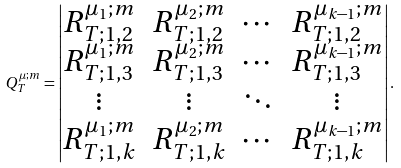Convert formula to latex. <formula><loc_0><loc_0><loc_500><loc_500>Q _ { T } ^ { \mu ; m } = \begin{vmatrix} R _ { T ; 1 , 2 } ^ { \mu _ { 1 } ; m } & R _ { T ; 1 , 2 } ^ { \mu _ { 2 } ; m } & \cdots & R _ { T ; 1 , 2 } ^ { \mu _ { k - 1 } ; m } \\ R _ { T ; 1 , 3 } ^ { \mu _ { 1 } ; m } & R _ { T ; 1 , 3 } ^ { \mu _ { 2 } ; m } & \cdots & R _ { T ; 1 , 3 } ^ { \mu _ { k - 1 } ; m } \\ \vdots & \vdots & \ddots & \vdots \\ R _ { T ; 1 , k } ^ { \mu _ { 1 } ; m } & R _ { T ; 1 , k } ^ { \mu _ { 2 } ; m } & \cdots & R _ { T ; 1 , k } ^ { \mu _ { k - 1 } ; m } \end{vmatrix} .</formula> 